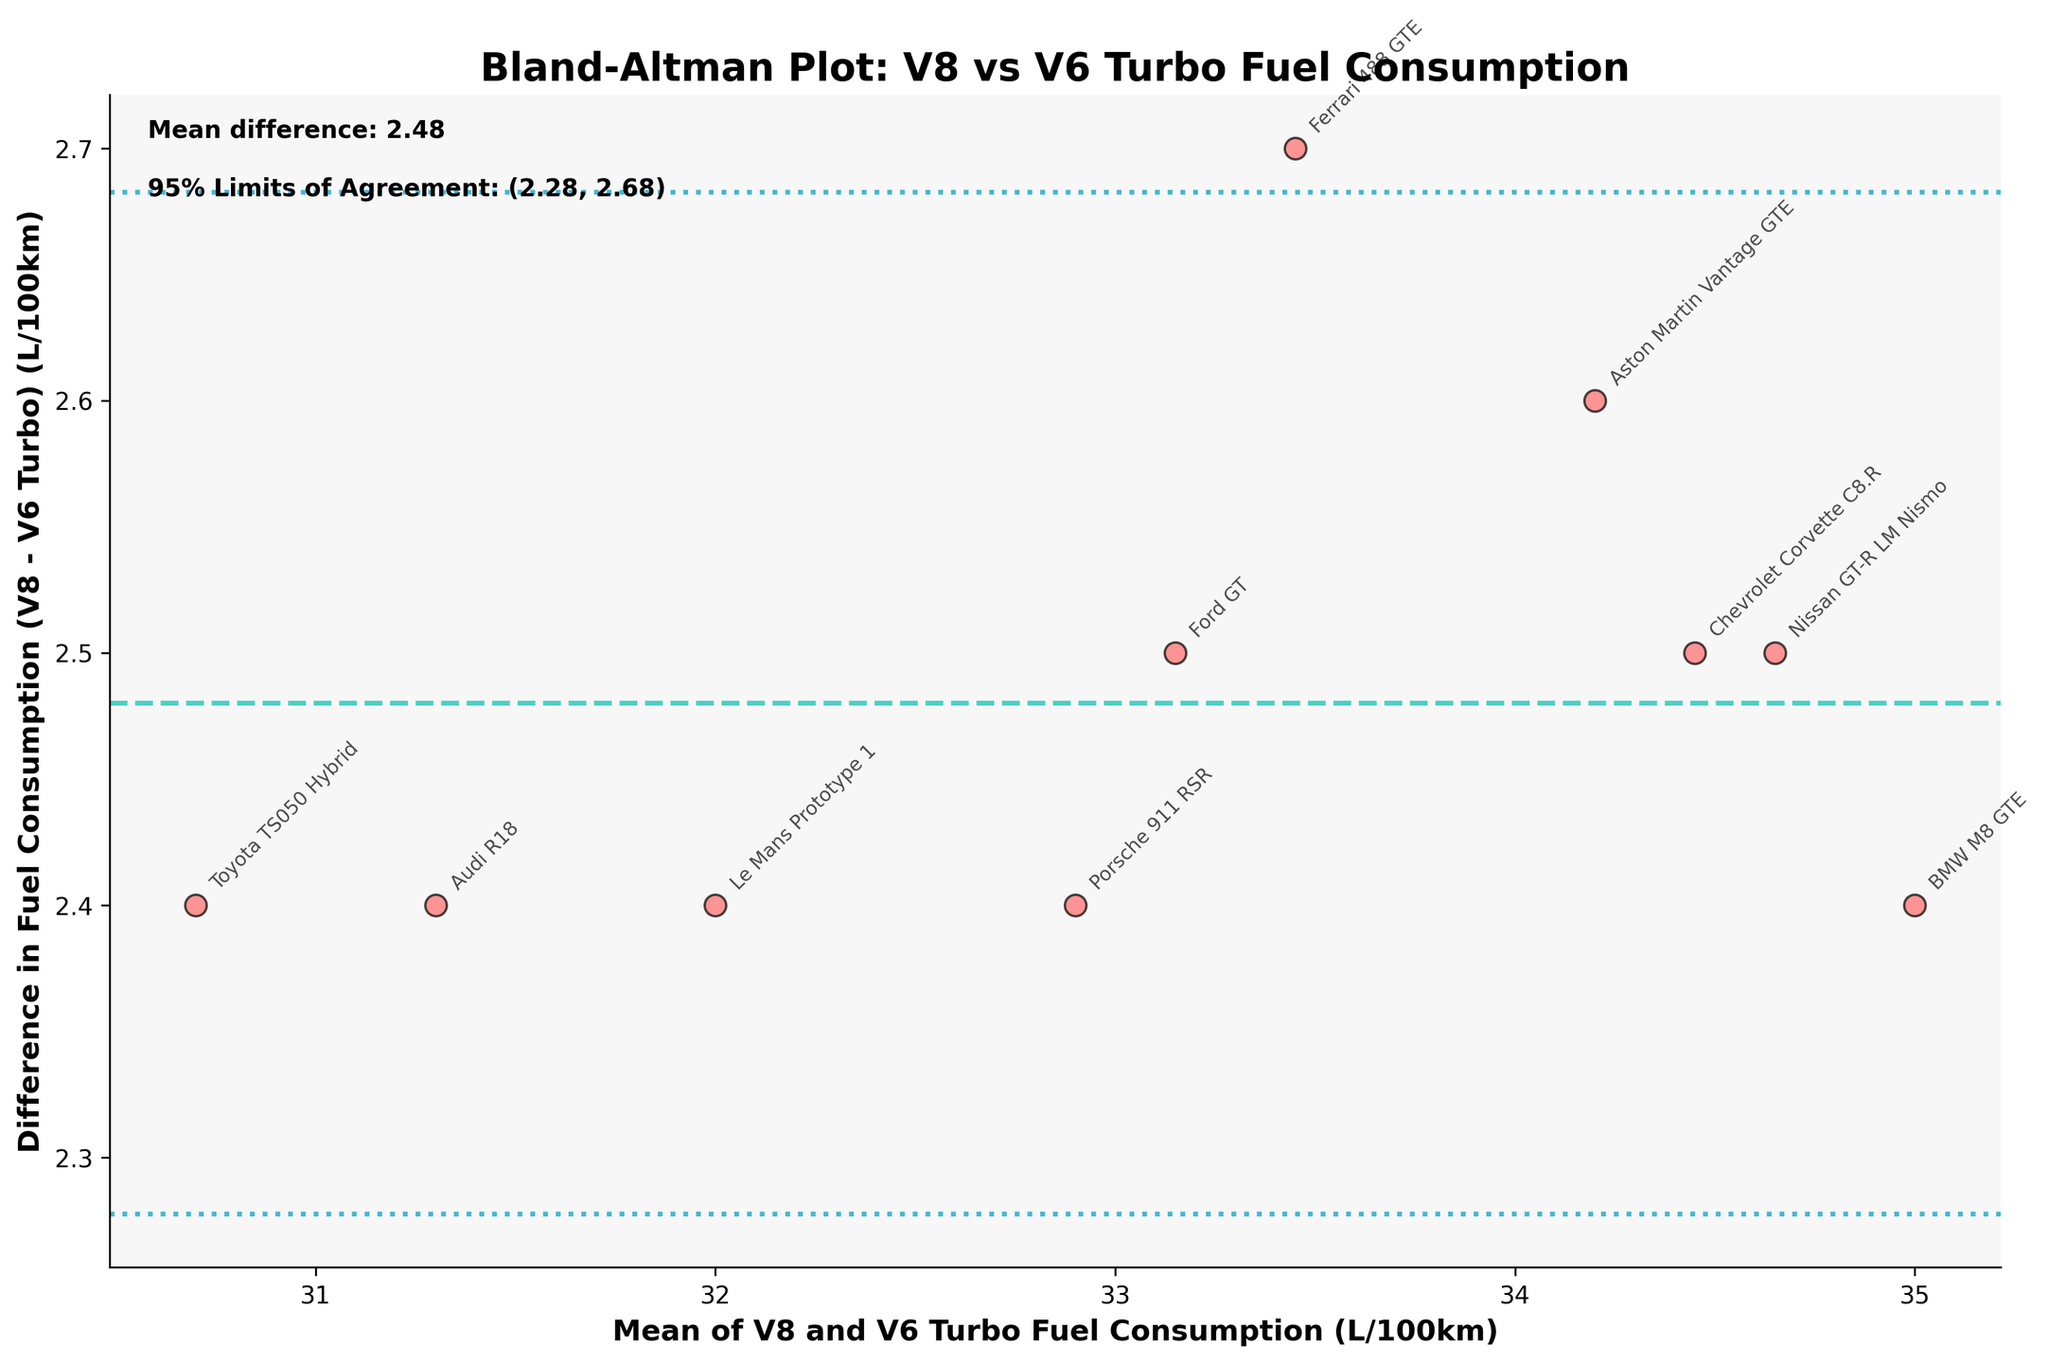What is the title of the plot? The title is prominently displayed at the top of the plot. It reads: "Bland-Altman Plot: V8 vs V6 Turbo Fuel Consumption".
Answer: Bland-Altman Plot: V8 vs V6 Turbo Fuel Consumption How many data points are plotted? The plot contains one data point for each car listed, which totals to 10.
Answer: 10 What does the y-axis represent? The y-axis represents the difference in fuel consumption (V8 - V6 Turbo) measured in L/100km. This is evident from the y-axis label.
Answer: Difference in Fuel Consumption (V8 - V6 Turbo) (L/100km) What does the x-axis represent? The x-axis shows the mean of V8 and V6 Turbo fuel consumption (L/100km). This is indicated by the x-axis label.
Answer: Mean of V8 and V6 Turbo Fuel Consumption (L/100km) What is the mean difference in fuel consumption between the two engine types? A textual annotation on the plot provides this information, indicating the mean difference is 2.77 L/100km.
Answer: 2.77 What are the 95% limits of agreement? The limits of agreement values are provided as an annotation on the plot. They are shown as (0.50, 5.04) L/100km.
Answer: (0.50, 5.04) Which car shows the largest difference in fuel consumption and how much is it? Visually inspecting the plot, the "Chevrolet Corvette C8.R" shows the largest difference. Its annotation is at the highest point on the y-axis (~2.5 L/100km).
Answer: Chevrolet Corvette C8.R, ~2.5 L/100km What is the general trend in the difference in fuel consumption as the mean fuel consumption increases? Observing the scatter plot, there is no visible trend indicating that differences in fuel consumption are not dependent on the mean fuel consumption. The points seem dispersed without a discernible pattern.
Answer: No discernible trend Which car has a mean fuel consumption closest to 34 L/100km, and what is its corresponding difference? The "Ferrari 488 GTE" is closest to the mean value of 34 L/100km, with a difference of roughly ~2.7 L/100km as indicated by its position on the plot.
Answer: Ferrari 488 GTE, ~2.7 L/100km 